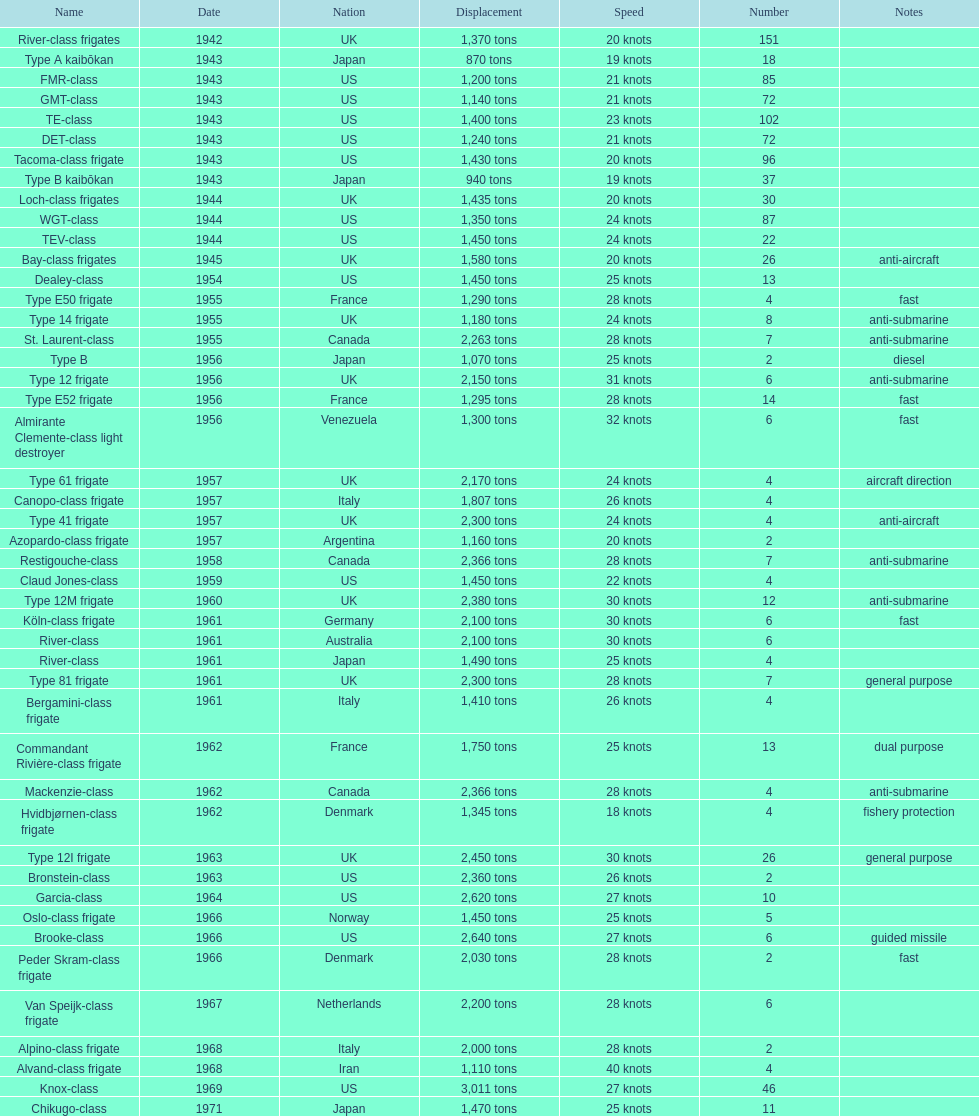Which name holds the biggest displacement? Knox-class. 